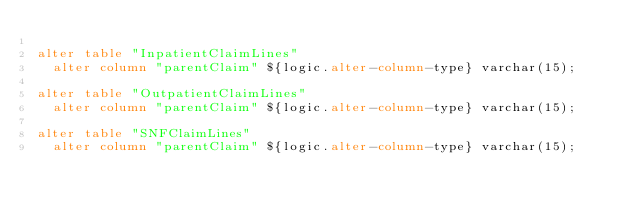Convert code to text. <code><loc_0><loc_0><loc_500><loc_500><_SQL_>
alter table "InpatientClaimLines"
  alter column "parentClaim" ${logic.alter-column-type} varchar(15);

alter table "OutpatientClaimLines"
  alter column "parentClaim" ${logic.alter-column-type} varchar(15);

alter table "SNFClaimLines"
  alter column "parentClaim" ${logic.alter-column-type} varchar(15);
</code> 